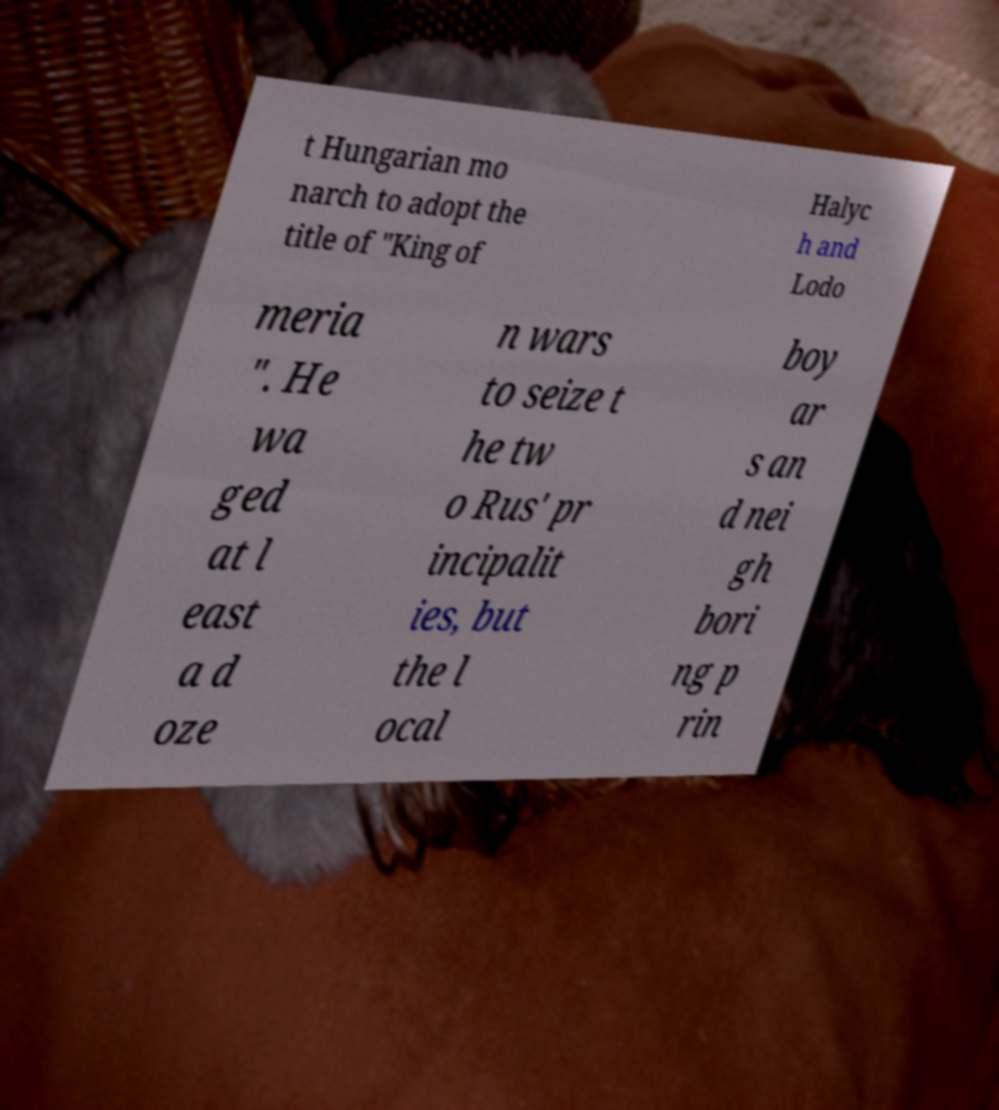For documentation purposes, I need the text within this image transcribed. Could you provide that? t Hungarian mo narch to adopt the title of "King of Halyc h and Lodo meria ". He wa ged at l east a d oze n wars to seize t he tw o Rus' pr incipalit ies, but the l ocal boy ar s an d nei gh bori ng p rin 